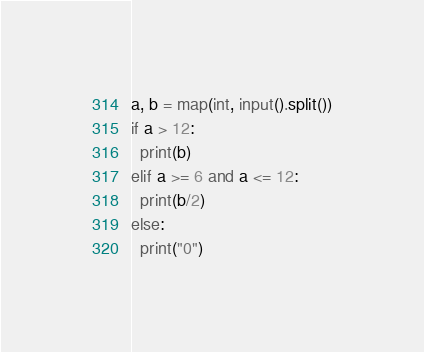<code> <loc_0><loc_0><loc_500><loc_500><_Python_>a, b = map(int, input().split())
if a > 12:
  print(b)
elif a >= 6 and a <= 12:
  print(b/2)
else:
  print("0")</code> 